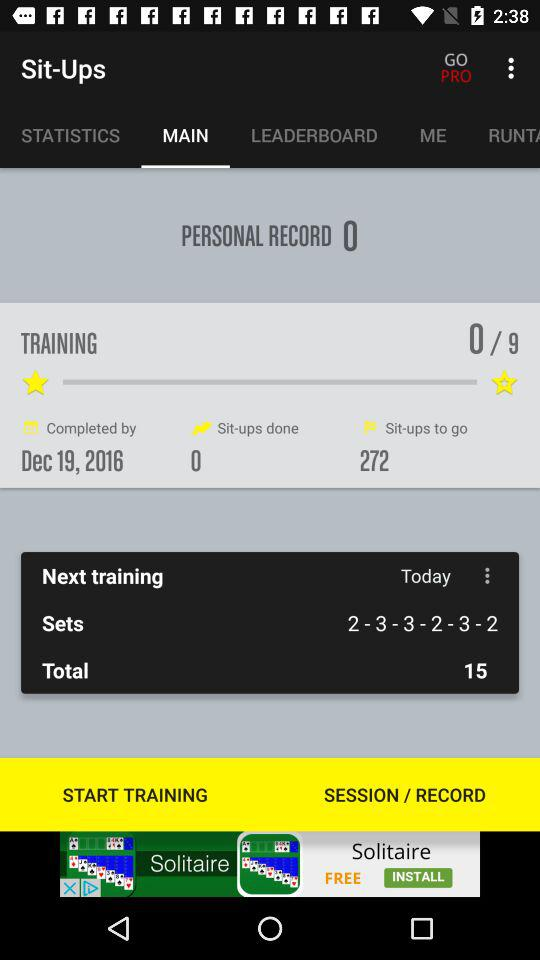How many sets do I need to complete this training?
Answer the question using a single word or phrase. 6 